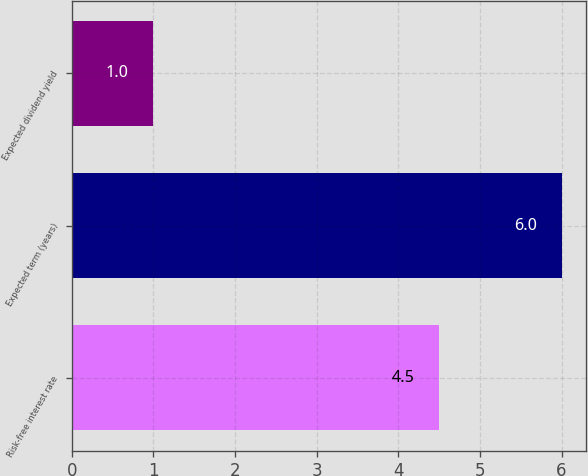Convert chart. <chart><loc_0><loc_0><loc_500><loc_500><bar_chart><fcel>Risk-free interest rate<fcel>Expected term (years)<fcel>Expected dividend yield<nl><fcel>4.5<fcel>6<fcel>1<nl></chart> 